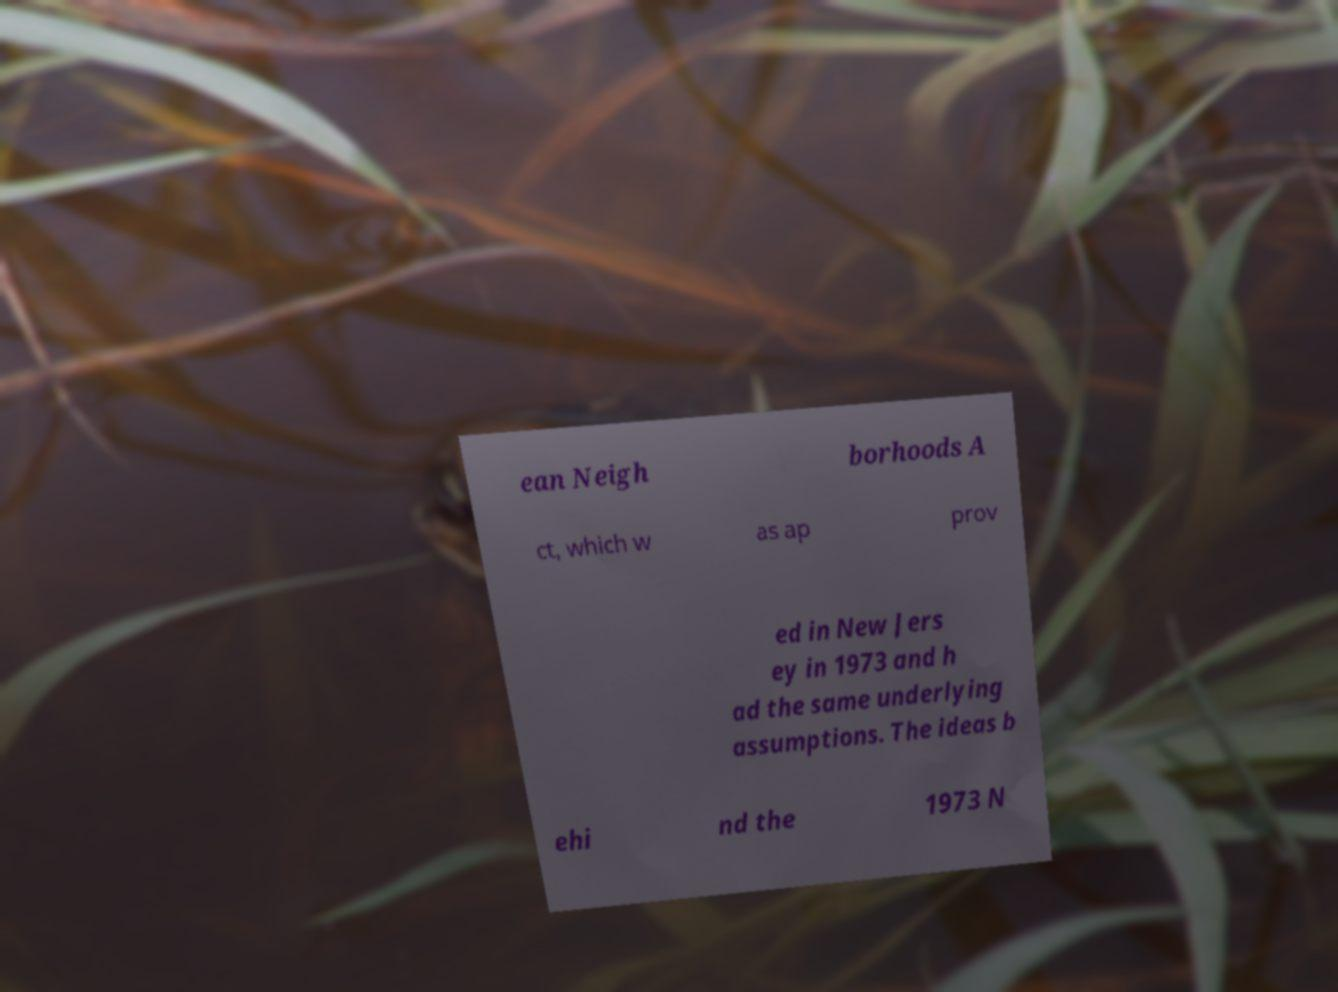Can you read and provide the text displayed in the image?This photo seems to have some interesting text. Can you extract and type it out for me? ean Neigh borhoods A ct, which w as ap prov ed in New Jers ey in 1973 and h ad the same underlying assumptions. The ideas b ehi nd the 1973 N 